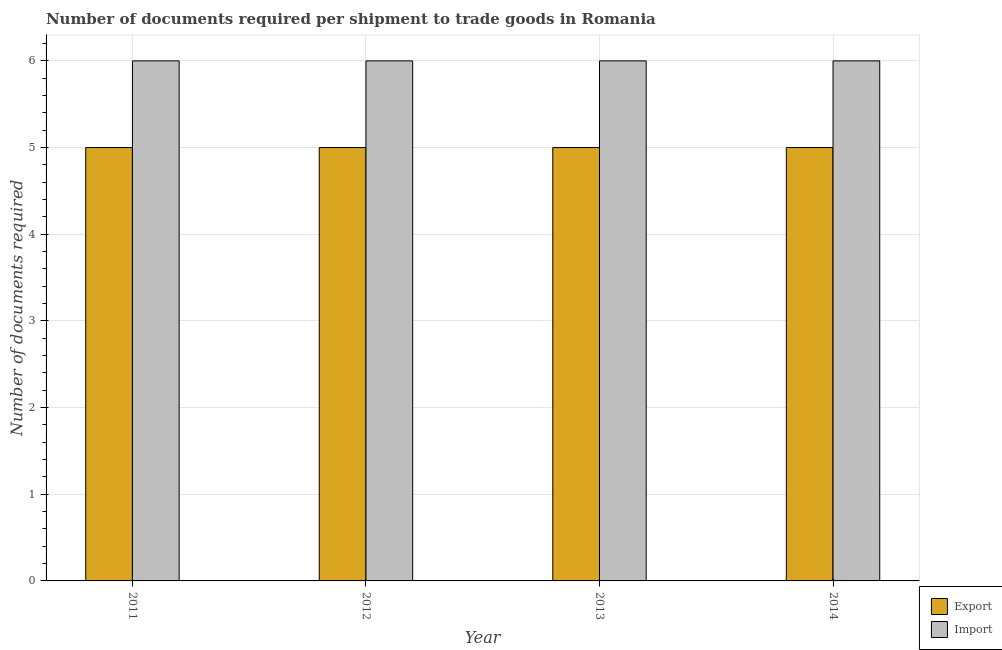How many different coloured bars are there?
Offer a terse response. 2. Are the number of bars on each tick of the X-axis equal?
Your response must be concise. Yes. How many bars are there on the 4th tick from the left?
Provide a short and direct response. 2. How many bars are there on the 4th tick from the right?
Make the answer very short. 2. What is the label of the 4th group of bars from the left?
Provide a short and direct response. 2014. In how many cases, is the number of bars for a given year not equal to the number of legend labels?
Your response must be concise. 0. What is the number of documents required to export goods in 2014?
Your answer should be very brief. 5. Across all years, what is the maximum number of documents required to export goods?
Your answer should be compact. 5. Across all years, what is the minimum number of documents required to export goods?
Keep it short and to the point. 5. In which year was the number of documents required to import goods maximum?
Your answer should be very brief. 2011. In which year was the number of documents required to import goods minimum?
Your answer should be very brief. 2011. What is the total number of documents required to import goods in the graph?
Your answer should be compact. 24. What is the difference between the number of documents required to export goods in 2011 and that in 2012?
Provide a short and direct response. 0. What is the difference between the number of documents required to import goods in 2013 and the number of documents required to export goods in 2014?
Make the answer very short. 0. In how many years, is the number of documents required to export goods greater than 2?
Keep it short and to the point. 4. Is the number of documents required to export goods in 2011 less than that in 2013?
Your response must be concise. No. What is the difference between the highest and the second highest number of documents required to import goods?
Offer a very short reply. 0. What is the difference between the highest and the lowest number of documents required to export goods?
Make the answer very short. 0. In how many years, is the number of documents required to export goods greater than the average number of documents required to export goods taken over all years?
Your answer should be very brief. 0. Is the sum of the number of documents required to export goods in 2011 and 2014 greater than the maximum number of documents required to import goods across all years?
Offer a very short reply. Yes. What does the 1st bar from the left in 2011 represents?
Your response must be concise. Export. What does the 2nd bar from the right in 2014 represents?
Your response must be concise. Export. How many bars are there?
Offer a very short reply. 8. How many years are there in the graph?
Ensure brevity in your answer.  4. What is the difference between two consecutive major ticks on the Y-axis?
Ensure brevity in your answer.  1. Are the values on the major ticks of Y-axis written in scientific E-notation?
Your answer should be compact. No. Does the graph contain any zero values?
Give a very brief answer. No. Does the graph contain grids?
Provide a succinct answer. Yes. How many legend labels are there?
Give a very brief answer. 2. What is the title of the graph?
Your answer should be compact. Number of documents required per shipment to trade goods in Romania. What is the label or title of the X-axis?
Your answer should be compact. Year. What is the label or title of the Y-axis?
Your answer should be very brief. Number of documents required. What is the Number of documents required of Export in 2013?
Your response must be concise. 5. What is the Number of documents required of Import in 2013?
Offer a terse response. 6. Across all years, what is the maximum Number of documents required of Import?
Provide a succinct answer. 6. Across all years, what is the minimum Number of documents required in Import?
Make the answer very short. 6. What is the difference between the Number of documents required in Export in 2011 and that in 2012?
Give a very brief answer. 0. What is the difference between the Number of documents required in Import in 2011 and that in 2013?
Your response must be concise. 0. What is the difference between the Number of documents required in Export in 2011 and that in 2014?
Give a very brief answer. 0. What is the difference between the Number of documents required of Import in 2011 and that in 2014?
Make the answer very short. 0. What is the difference between the Number of documents required in Export in 2012 and that in 2013?
Your response must be concise. 0. What is the difference between the Number of documents required in Export in 2013 and that in 2014?
Provide a succinct answer. 0. What is the difference between the Number of documents required in Import in 2013 and that in 2014?
Your answer should be very brief. 0. What is the difference between the Number of documents required in Export in 2011 and the Number of documents required in Import in 2014?
Your response must be concise. -1. What is the difference between the Number of documents required in Export in 2012 and the Number of documents required in Import in 2013?
Ensure brevity in your answer.  -1. What is the difference between the Number of documents required of Export in 2013 and the Number of documents required of Import in 2014?
Give a very brief answer. -1. In the year 2011, what is the difference between the Number of documents required in Export and Number of documents required in Import?
Offer a terse response. -1. In the year 2013, what is the difference between the Number of documents required in Export and Number of documents required in Import?
Make the answer very short. -1. In the year 2014, what is the difference between the Number of documents required of Export and Number of documents required of Import?
Your response must be concise. -1. What is the ratio of the Number of documents required in Export in 2011 to that in 2012?
Your answer should be very brief. 1. What is the ratio of the Number of documents required in Import in 2011 to that in 2012?
Give a very brief answer. 1. What is the ratio of the Number of documents required in Export in 2011 to that in 2013?
Make the answer very short. 1. What is the ratio of the Number of documents required in Export in 2012 to that in 2013?
Keep it short and to the point. 1. What is the ratio of the Number of documents required of Import in 2012 to that in 2014?
Give a very brief answer. 1. What is the ratio of the Number of documents required in Import in 2013 to that in 2014?
Your answer should be very brief. 1. What is the difference between the highest and the second highest Number of documents required of Export?
Offer a terse response. 0. What is the difference between the highest and the second highest Number of documents required of Import?
Your response must be concise. 0. What is the difference between the highest and the lowest Number of documents required of Import?
Provide a succinct answer. 0. 